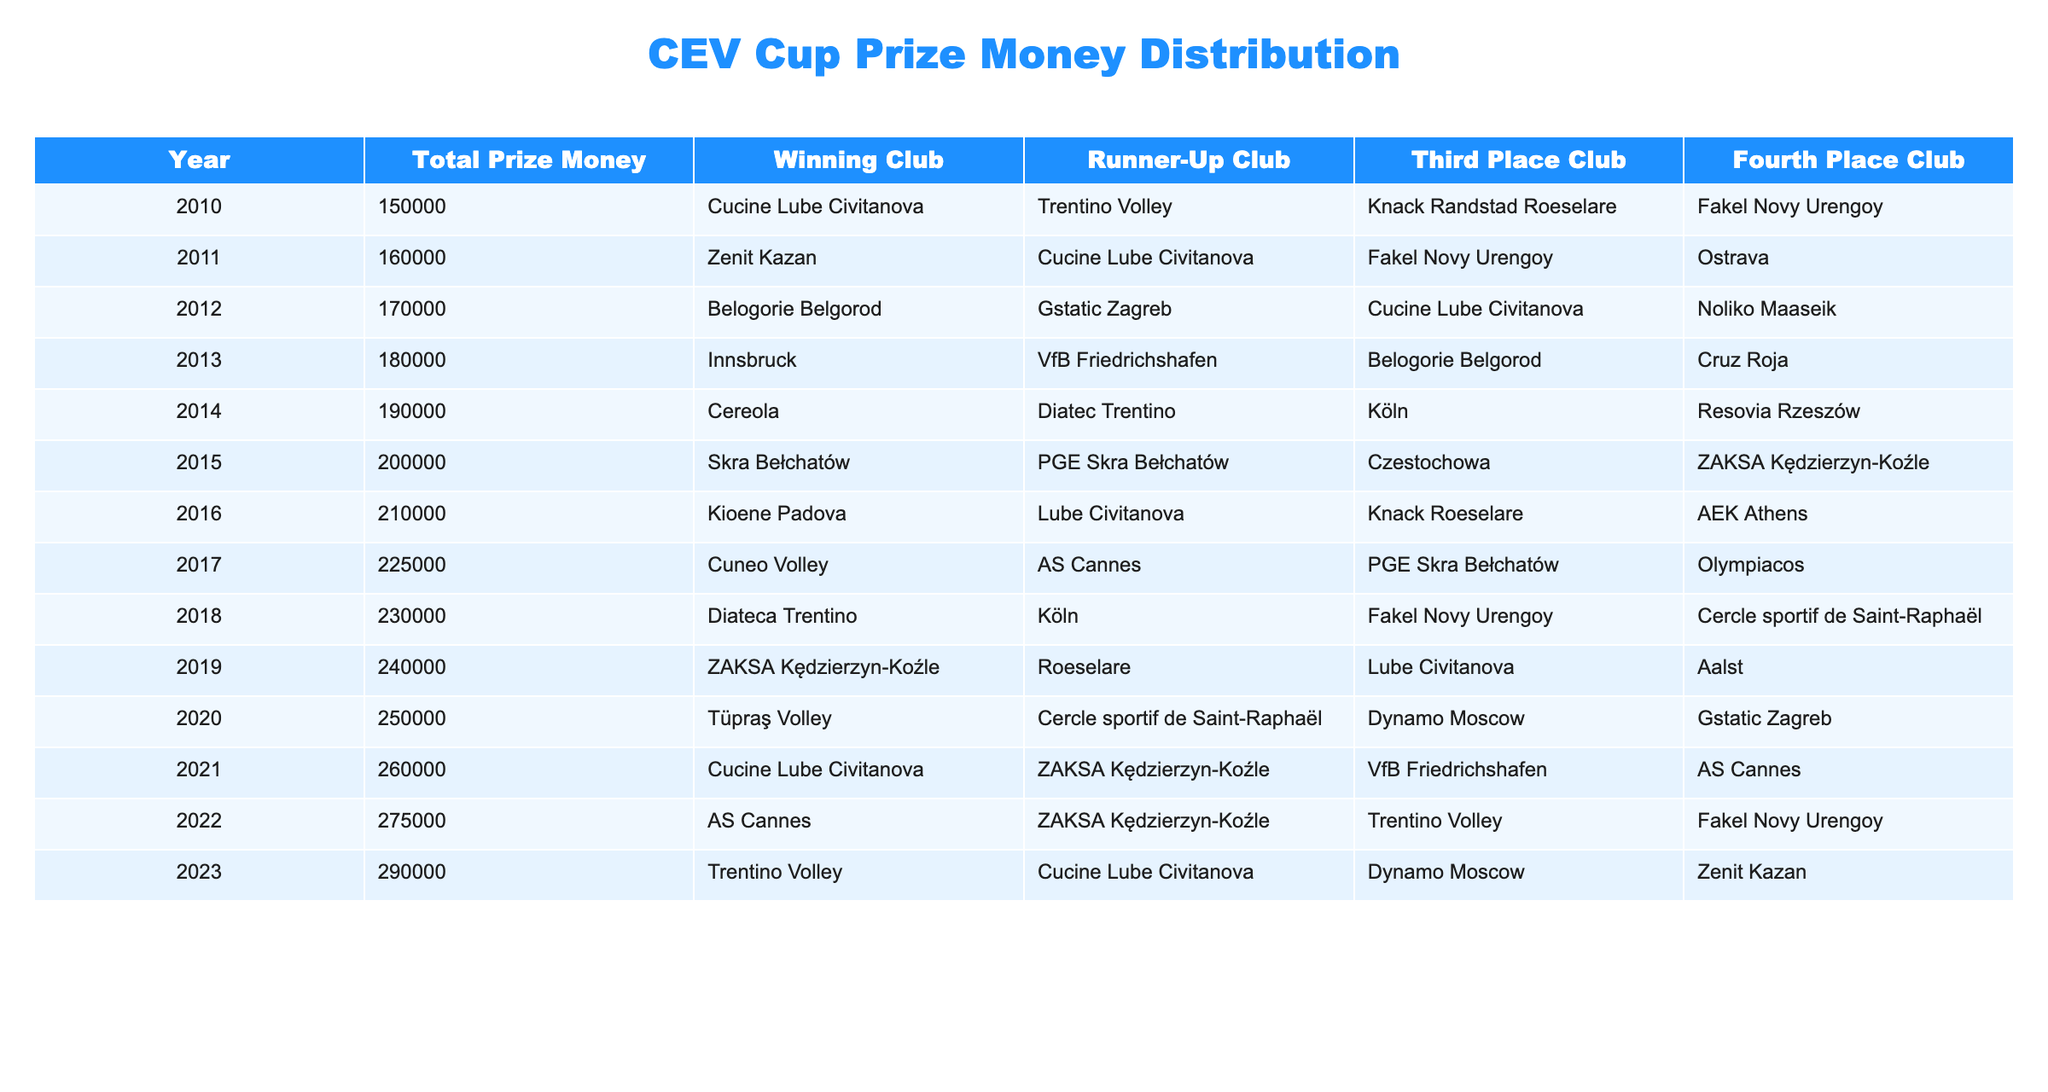What was the total prize money in 2015? In the 2015 row of the table, the total prize money is explicitly listed as 200000.
Answer: 200000 Which club won the CEV Cup in 2012? Looking at the 2012 row in the table, the winning club is stated to be Belogorie Belgorod.
Answer: Belogorie Belgorod How much did the prize money increase from 2010 to 2023? The total prize money in 2010 is 150000 and in 2023 it is 290000. To find the increase, subtract 150000 from 290000, which equals 140000.
Answer: 140000 Did Cucine Lube Civitanova win the Cup more than twice? To answer this, we check the winning club column for Cucine Lube Civitanova: it appears as the winning club in 2010, 2011, 2016, and 2021, for a total of four times. Therefore, the statement is true.
Answer: Yes What is the average total prize money from 2010 to 2023? First, sum the total prize money for all years: 150000 + 160000 + 170000 + 180000 + 190000 + 200000 + 210000 + 225000 + 230000 + 240000 + 250000 + 260000 + 275000 + 290000 =  3275000. Then, divide by the number of years (14), resulting in an average of 233214.29, which can be rounded to 233214.
Answer: 233214 Which club appeared as runner-up in 2021? Referring to the table entry for 2021, the runner-up club is ZAKSA Kędzierzyn-Koźle.
Answer: ZAKSA Kędzierzyn-Koźle Was the total prize money higher in 2019 than in 2020? Checking the prize money amounts, 2019 has 240000 and 2020 has 250000. Since 250000 is greater than 240000, the answer to this question is true.
Answer: No In which years did the runner-up club also appear as a winning club? To determine this, we look at the runner-up clubs and check against the winning clubs. The only years where the runner-up (Cucine Lube Civitanova in 2011 and ZAKSA Kędzierzyn-Koźle in 2022) also appears as a winning club are 2011 and 2022. Therefore, these two years meet the criteria.
Answer: 2011 and 2022 What was the total prize money for the winning clubs in the years 2014 and 2015? For 2014, the prize money was 190000, and for 2015, it was 200000. Adding these two amounts gives us a total of 390000.
Answer: 390000 